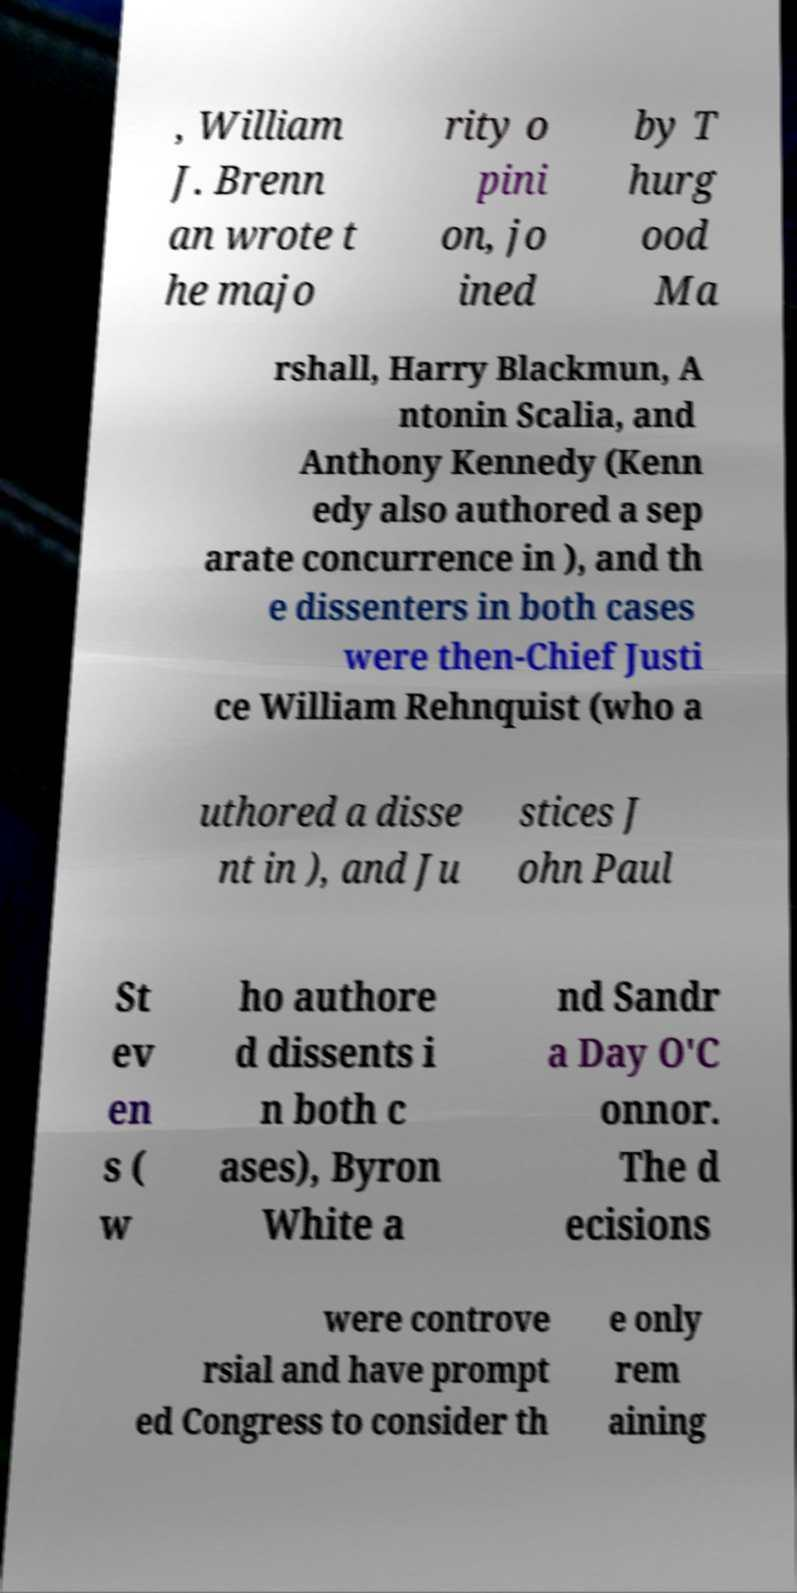There's text embedded in this image that I need extracted. Can you transcribe it verbatim? , William J. Brenn an wrote t he majo rity o pini on, jo ined by T hurg ood Ma rshall, Harry Blackmun, A ntonin Scalia, and Anthony Kennedy (Kenn edy also authored a sep arate concurrence in ), and th e dissenters in both cases were then-Chief Justi ce William Rehnquist (who a uthored a disse nt in ), and Ju stices J ohn Paul St ev en s ( w ho authore d dissents i n both c ases), Byron White a nd Sandr a Day O'C onnor. The d ecisions were controve rsial and have prompt ed Congress to consider th e only rem aining 